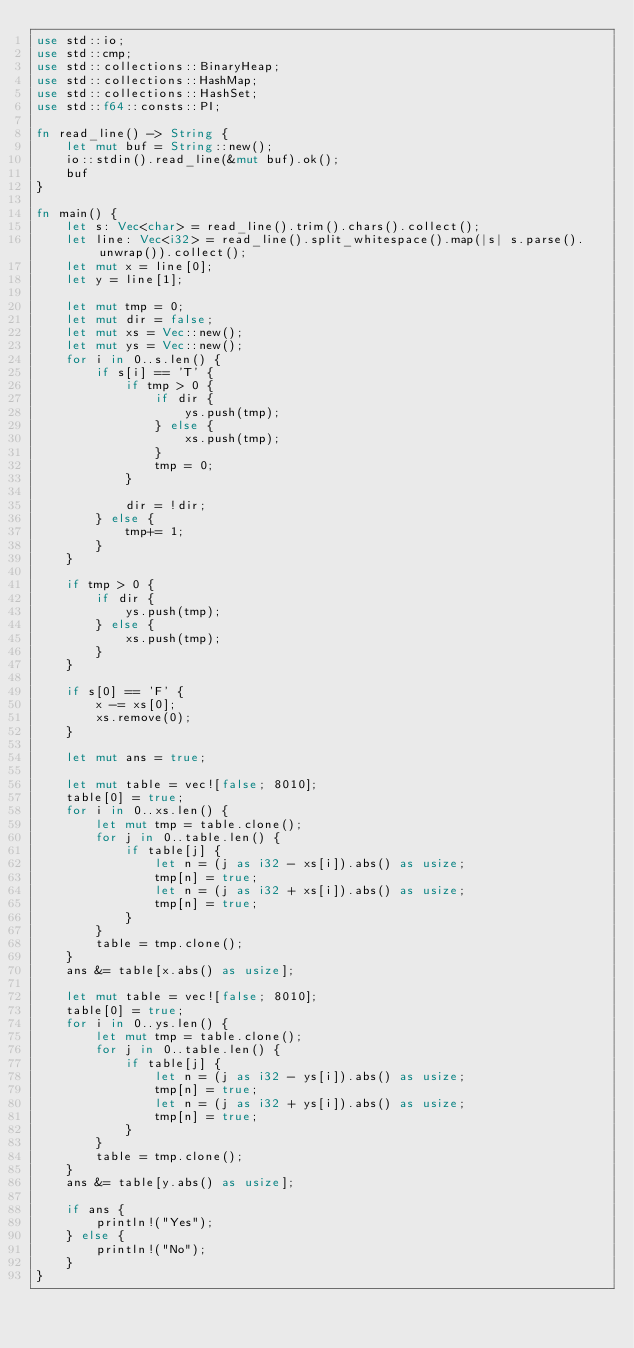Convert code to text. <code><loc_0><loc_0><loc_500><loc_500><_Rust_>use std::io;
use std::cmp;
use std::collections::BinaryHeap;
use std::collections::HashMap;
use std::collections::HashSet;
use std::f64::consts::PI;

fn read_line() -> String {
    let mut buf = String::new();
    io::stdin().read_line(&mut buf).ok();
    buf
}

fn main() {
    let s: Vec<char> = read_line().trim().chars().collect();
    let line: Vec<i32> = read_line().split_whitespace().map(|s| s.parse().unwrap()).collect();
    let mut x = line[0];
    let y = line[1];

    let mut tmp = 0;
    let mut dir = false;
    let mut xs = Vec::new();
    let mut ys = Vec::new();
    for i in 0..s.len() {
        if s[i] == 'T' {
            if tmp > 0 {
                if dir {
                    ys.push(tmp);
                } else {
                    xs.push(tmp);
                }
                tmp = 0;
            }

            dir = !dir;
        } else {
            tmp+= 1;
        }
    }

    if tmp > 0 {
        if dir {
            ys.push(tmp);
        } else {
            xs.push(tmp);
        }
    }

    if s[0] == 'F' {
        x -= xs[0];
        xs.remove(0);
    }

    let mut ans = true;

    let mut table = vec![false; 8010];
    table[0] = true;
    for i in 0..xs.len() {
        let mut tmp = table.clone();
        for j in 0..table.len() {
            if table[j] {
                let n = (j as i32 - xs[i]).abs() as usize;
                tmp[n] = true;
                let n = (j as i32 + xs[i]).abs() as usize;
                tmp[n] = true;
            }
        }
        table = tmp.clone();
    }
    ans &= table[x.abs() as usize];
    
    let mut table = vec![false; 8010];
    table[0] = true;
    for i in 0..ys.len() {
        let mut tmp = table.clone();
        for j in 0..table.len() {
            if table[j] {
                let n = (j as i32 - ys[i]).abs() as usize;
                tmp[n] = true;
                let n = (j as i32 + ys[i]).abs() as usize;
                tmp[n] = true;
            }
        }
        table = tmp.clone();
    }
    ans &= table[y.abs() as usize];

    if ans {
        println!("Yes");
    } else {
        println!("No");
    }
}
</code> 